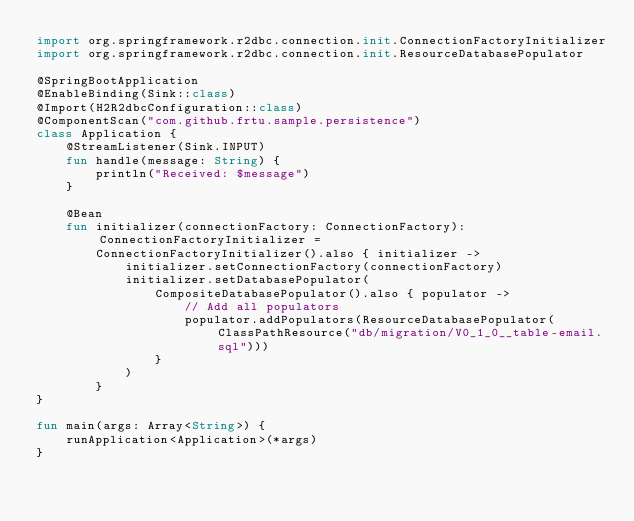Convert code to text. <code><loc_0><loc_0><loc_500><loc_500><_Kotlin_>import org.springframework.r2dbc.connection.init.ConnectionFactoryInitializer
import org.springframework.r2dbc.connection.init.ResourceDatabasePopulator

@SpringBootApplication
@EnableBinding(Sink::class)
@Import(H2R2dbcConfiguration::class)
@ComponentScan("com.github.frtu.sample.persistence")
class Application {
    @StreamListener(Sink.INPUT)
    fun handle(message: String) {
        println("Received: $message")
    }

    @Bean
    fun initializer(connectionFactory: ConnectionFactory): ConnectionFactoryInitializer =
        ConnectionFactoryInitializer().also { initializer ->
            initializer.setConnectionFactory(connectionFactory)
            initializer.setDatabasePopulator(
                CompositeDatabasePopulator().also { populator ->
                    // Add all populators
                    populator.addPopulators(ResourceDatabasePopulator(ClassPathResource("db/migration/V0_1_0__table-email.sql")))
                }
            )
        }
}

fun main(args: Array<String>) {
    runApplication<Application>(*args)
}
</code> 